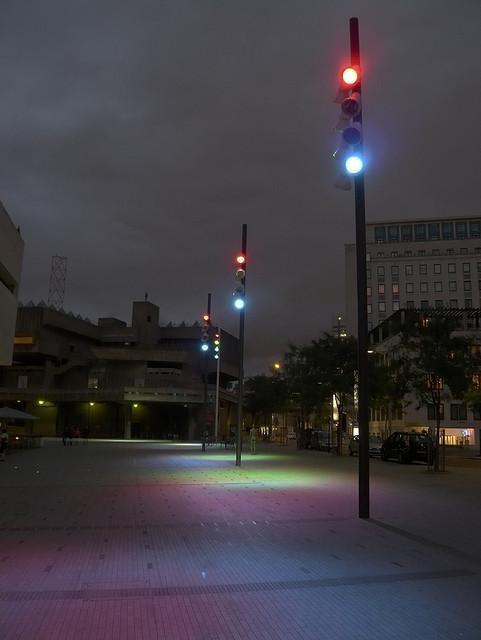How many lights are red?
Give a very brief answer. 3. How many street lights are there?
Give a very brief answer. 3. 